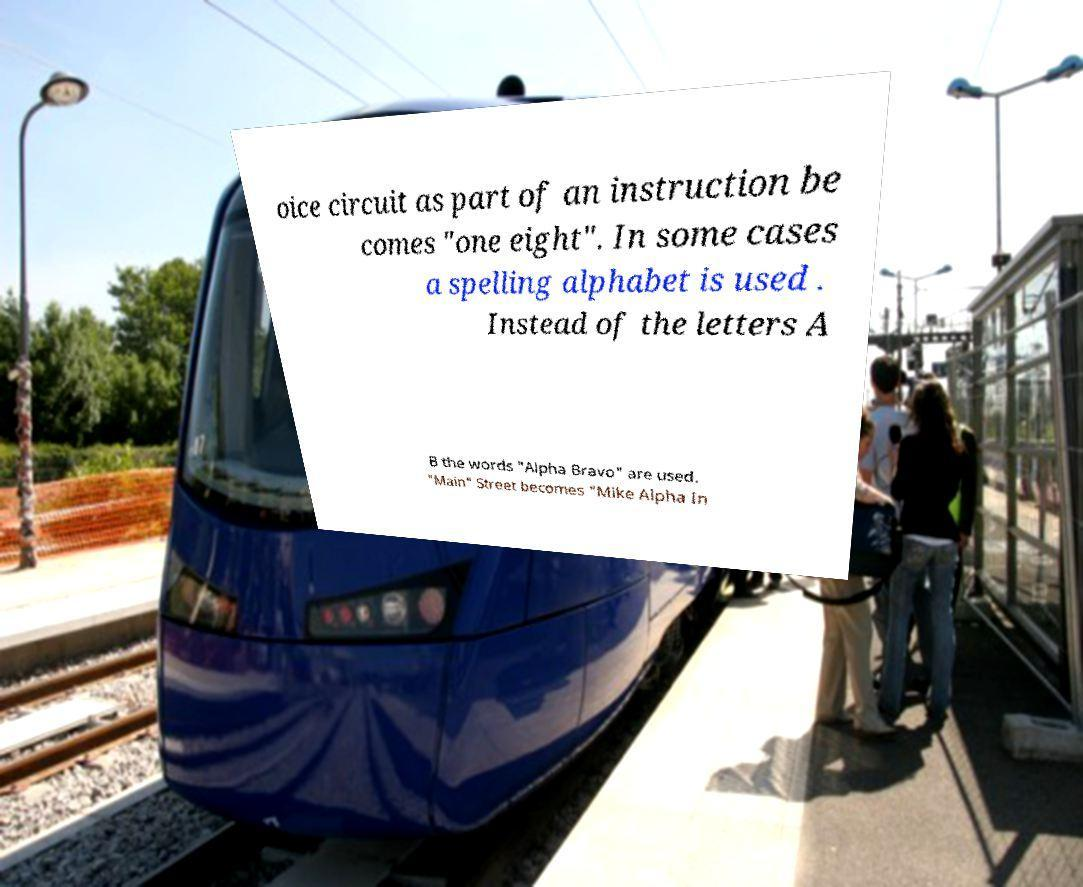Please identify and transcribe the text found in this image. oice circuit as part of an instruction be comes "one eight". In some cases a spelling alphabet is used . Instead of the letters A B the words "Alpha Bravo" are used. "Main" Street becomes "Mike Alpha In 